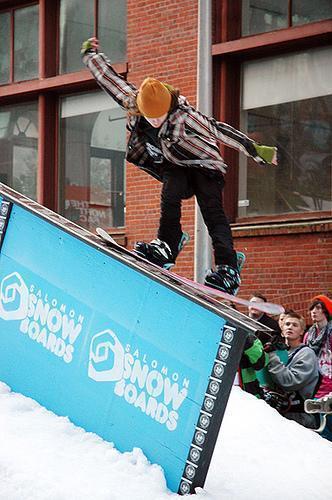What is this wall used for?
Choose the correct response and explain in the format: 'Answer: answer
Rationale: rationale.'
Options: Pictures, plants, snowboarding, door. Answer: snowboarding.
Rationale: The word snowboards is written on the wall and there is a snowboarder actively using it. it was likely intentionally placed there for this purpose. 